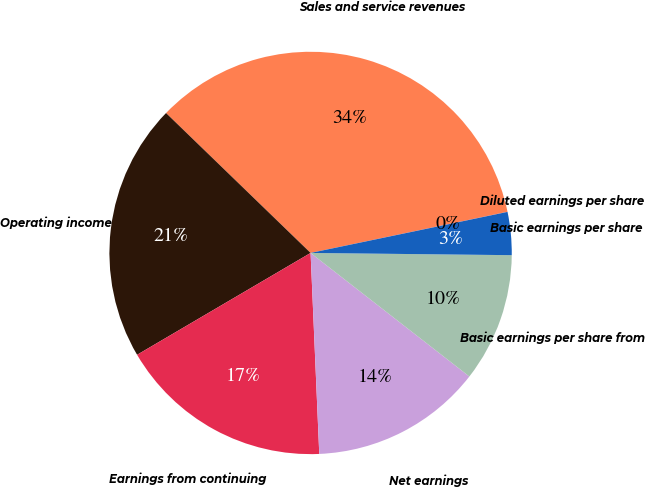<chart> <loc_0><loc_0><loc_500><loc_500><pie_chart><fcel>Sales and service revenues<fcel>Operating income<fcel>Earnings from continuing<fcel>Net earnings<fcel>Basic earnings per share from<fcel>Basic earnings per share<fcel>Diluted earnings per share<nl><fcel>34.48%<fcel>20.69%<fcel>17.24%<fcel>13.79%<fcel>10.35%<fcel>3.45%<fcel>0.01%<nl></chart> 